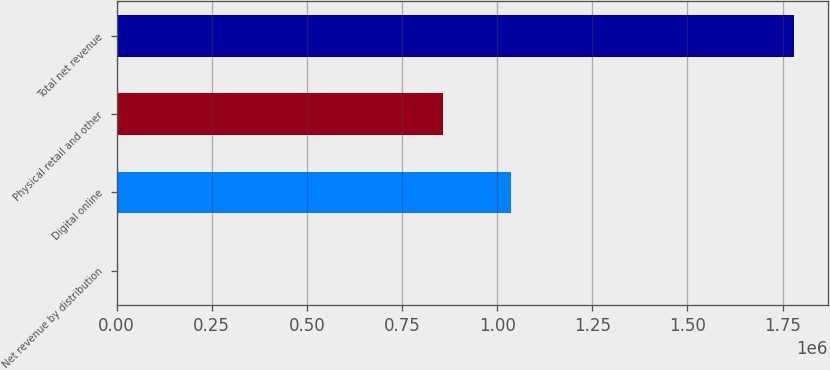Convert chart. <chart><loc_0><loc_0><loc_500><loc_500><bar_chart><fcel>Net revenue by distribution<fcel>Digital online<fcel>Physical retail and other<fcel>Total net revenue<nl><fcel>2017<fcel>1.03579e+06<fcel>858014<fcel>1.77975e+06<nl></chart> 